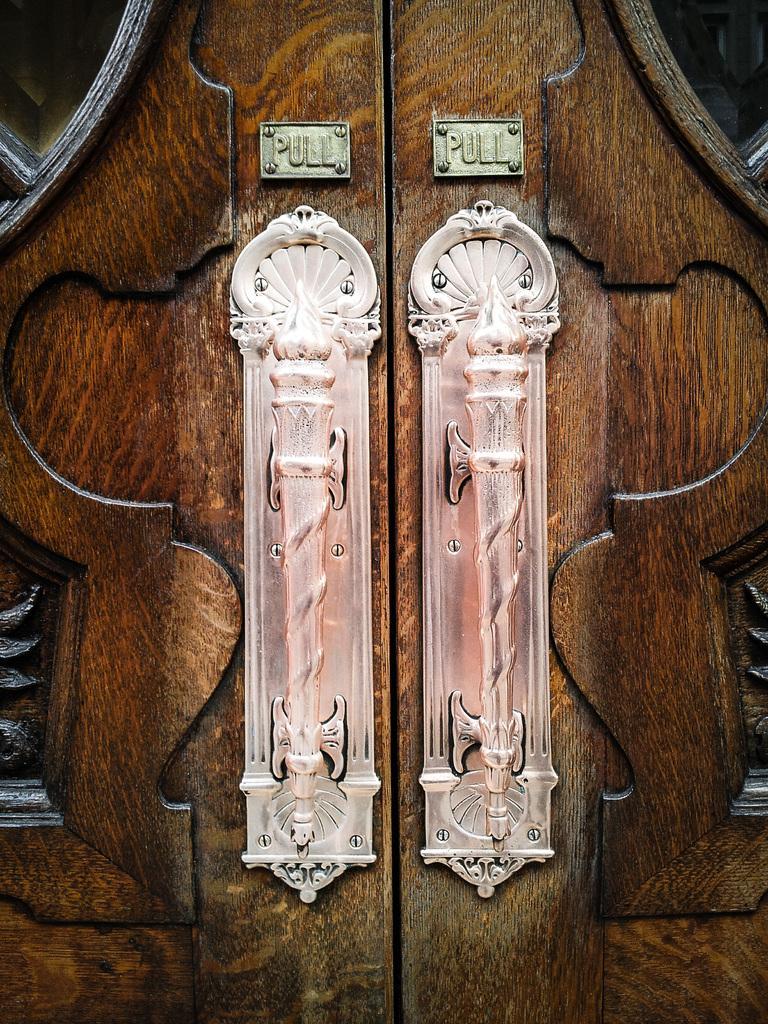In one or two sentences, can you explain what this image depicts? In this image I can see brown colour doors and on it I can see two handles and two boards. On these words I can see "pull" is written. 